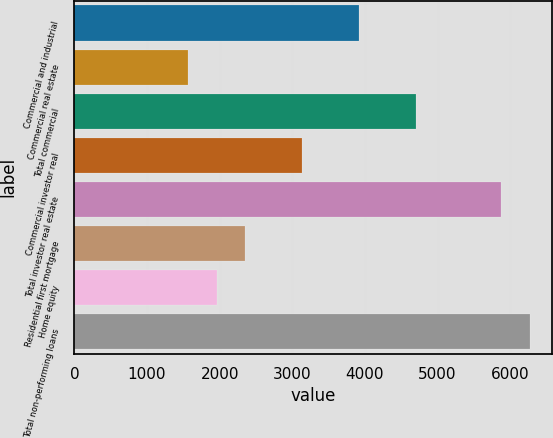Convert chart to OTSL. <chart><loc_0><loc_0><loc_500><loc_500><bar_chart><fcel>Commercial and industrial<fcel>Commercial real estate<fcel>Total commercial<fcel>Commercial investor real<fcel>Total investor real estate<fcel>Residential first mortgage<fcel>Home equity<fcel>Total non-performing loans<nl><fcel>3918<fcel>1568.4<fcel>4701.2<fcel>3134.8<fcel>5876<fcel>2351.6<fcel>1960<fcel>6267.6<nl></chart> 